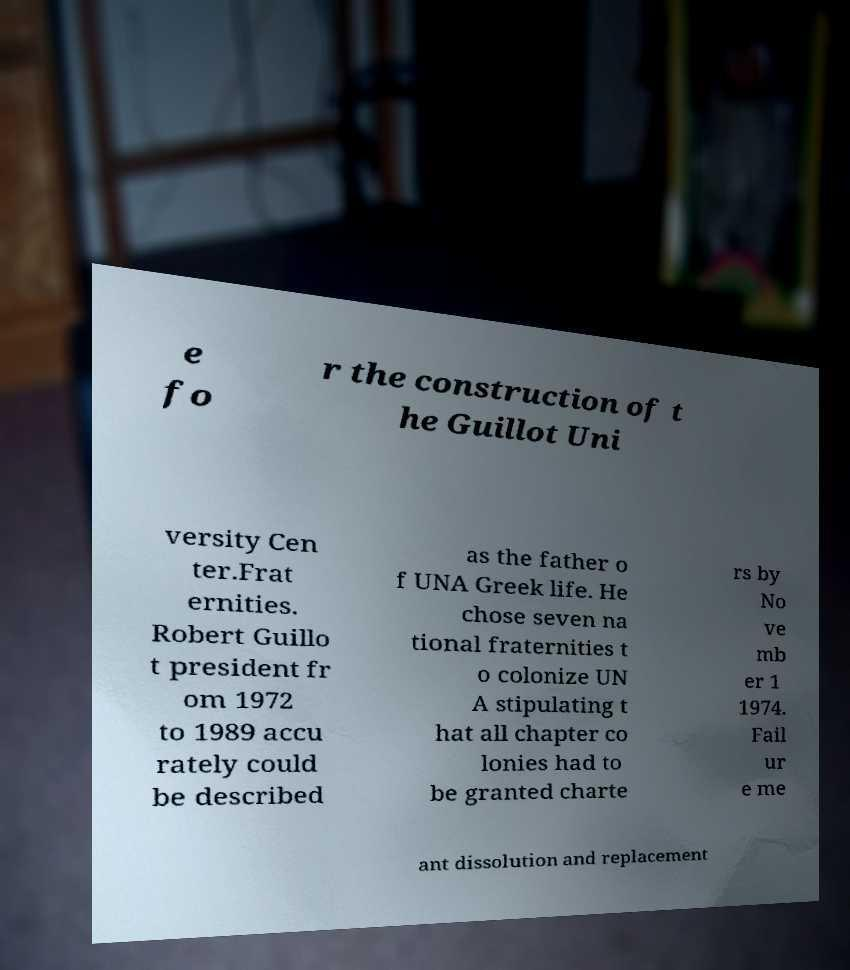Please read and relay the text visible in this image. What does it say? e fo r the construction of t he Guillot Uni versity Cen ter.Frat ernities. Robert Guillo t president fr om 1972 to 1989 accu rately could be described as the father o f UNA Greek life. He chose seven na tional fraternities t o colonize UN A stipulating t hat all chapter co lonies had to be granted charte rs by No ve mb er 1 1974. Fail ur e me ant dissolution and replacement 